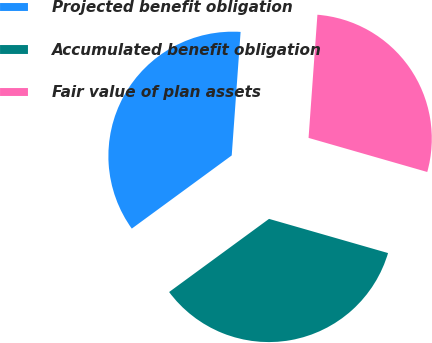Convert chart. <chart><loc_0><loc_0><loc_500><loc_500><pie_chart><fcel>Projected benefit obligation<fcel>Accumulated benefit obligation<fcel>Fair value of plan assets<nl><fcel>36.2%<fcel>35.49%<fcel>28.31%<nl></chart> 